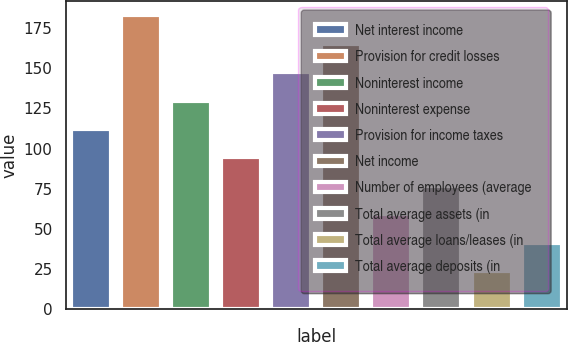Convert chart. <chart><loc_0><loc_0><loc_500><loc_500><bar_chart><fcel>Net interest income<fcel>Provision for credit losses<fcel>Noninterest income<fcel>Noninterest expense<fcel>Provision for income taxes<fcel>Net income<fcel>Number of employees (average<fcel>Total average assets (in<fcel>Total average loans/leases (in<fcel>Total average deposits (in<nl><fcel>112.2<fcel>183<fcel>129.9<fcel>94.5<fcel>147.6<fcel>165.3<fcel>59.1<fcel>76.8<fcel>23.7<fcel>41.4<nl></chart> 